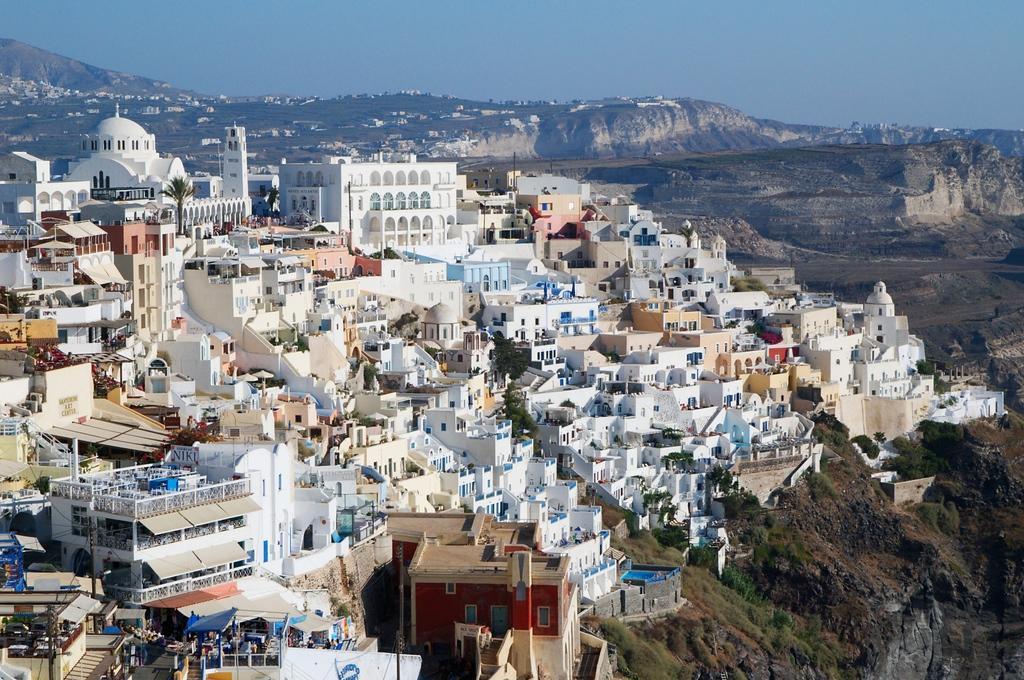How would you summarize this image in a sentence or two? In the image in the center we can see buildings,wall,trees,roof,windows,staircase,compound wall,poles and group of people were standing. In the background we can see sky,hill,trees,buildings,grass etc. 